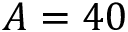<formula> <loc_0><loc_0><loc_500><loc_500>A = 4 0</formula> 